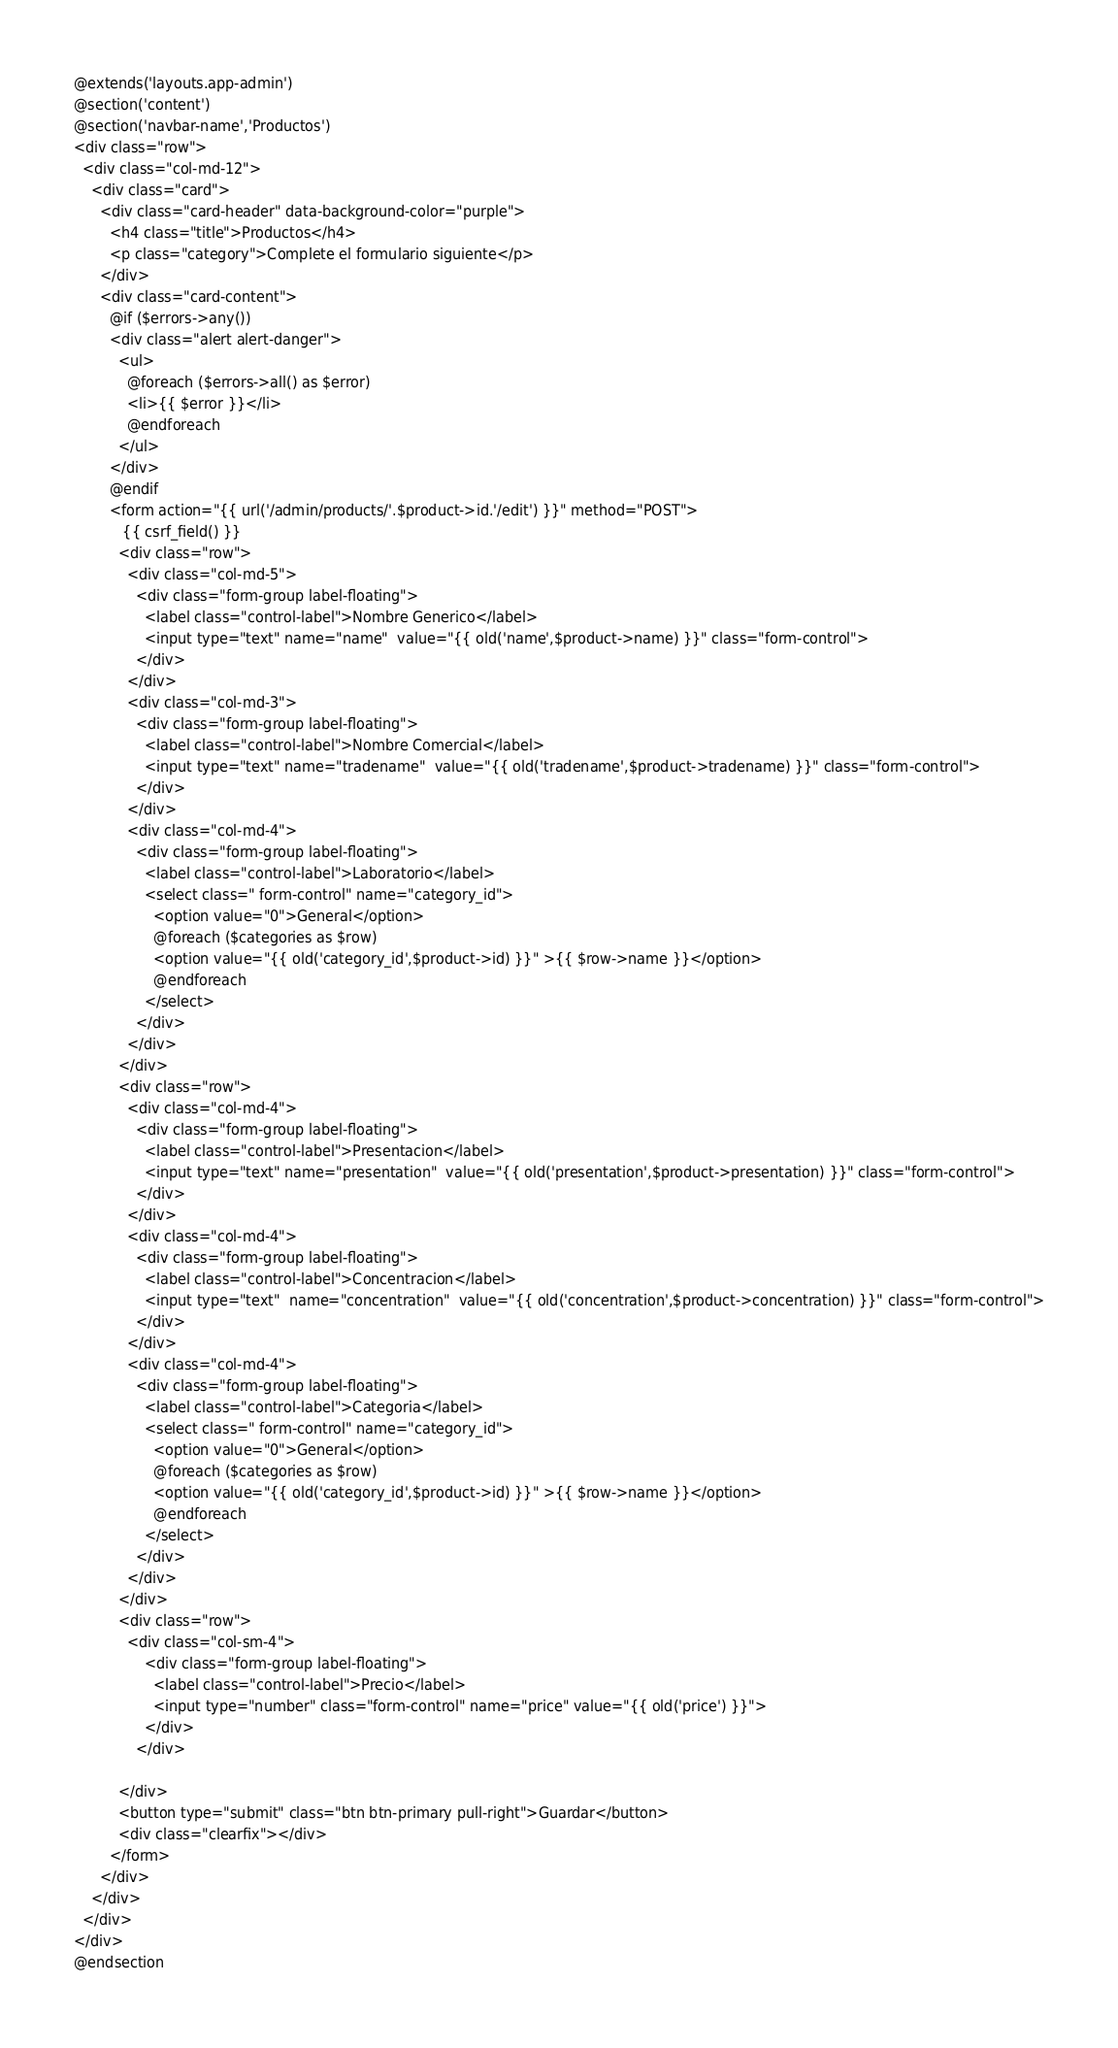<code> <loc_0><loc_0><loc_500><loc_500><_PHP_>@extends('layouts.app-admin')
@section('content')
@section('navbar-name','Productos')
<div class="row">
  <div class="col-md-12">
    <div class="card">
      <div class="card-header" data-background-color="purple">
        <h4 class="title">Productos</h4>
        <p class="category">Complete el formulario siguiente</p>
      </div>
      <div class="card-content">
        @if ($errors->any())
        <div class="alert alert-danger">
          <ul>
            @foreach ($errors->all() as $error)
            <li>{{ $error }}</li>
            @endforeach
          </ul>
        </div>
        @endif
        <form action="{{ url('/admin/products/'.$product->id.'/edit') }}" method="POST">
           {{ csrf_field() }}
          <div class="row">
            <div class="col-md-5">
              <div class="form-group label-floating">
                <label class="control-label">Nombre Generico</label>
                <input type="text" name="name"  value="{{ old('name',$product->name) }}" class="form-control">
              </div>
            </div>
            <div class="col-md-3">
              <div class="form-group label-floating">
                <label class="control-label">Nombre Comercial</label>
                <input type="text" name="tradename"  value="{{ old('tradename',$product->tradename) }}" class="form-control">
              </div>
            </div>
            <div class="col-md-4">
              <div class="form-group label-floating">
                <label class="control-label">Laboratorio</label>
                <select class=" form-control" name="category_id">
                  <option value="0">General</option>
                  @foreach ($categories as $row)
                  <option value="{{ old('category_id',$product->id) }}" >{{ $row->name }}</option>
                  @endforeach
                </select>
              </div>
            </div>
          </div>
          <div class="row">
            <div class="col-md-4">
              <div class="form-group label-floating">
                <label class="control-label">Presentacion</label>
                <input type="text" name="presentation"  value="{{ old('presentation',$product->presentation) }}" class="form-control">
              </div>
            </div>
            <div class="col-md-4">
              <div class="form-group label-floating">
                <label class="control-label">Concentracion</label>
                <input type="text"  name="concentration"  value="{{ old('concentration',$product->concentration) }}" class="form-control">
              </div>
            </div>
            <div class="col-md-4">
              <div class="form-group label-floating">
                <label class="control-label">Categoria</label>
                <select class=" form-control" name="category_id">
                  <option value="0">General</option>
                  @foreach ($categories as $row)
                  <option value="{{ old('category_id',$product->id) }}" >{{ $row->name }}</option>
                  @endforeach
                </select>
              </div>
            </div>
          </div>
          <div class="row">
            <div class="col-sm-4">
                <div class="form-group label-floating">
                  <label class="control-label">Precio</label>
                  <input type="number" class="form-control" name="price" value="{{ old('price') }}">
                </div>
              </div>

          </div>
          <button type="submit" class="btn btn-primary pull-right">Guardar</button>
          <div class="clearfix"></div>
        </form>
      </div>
    </div>
  </div>
</div>
@endsection
</code> 